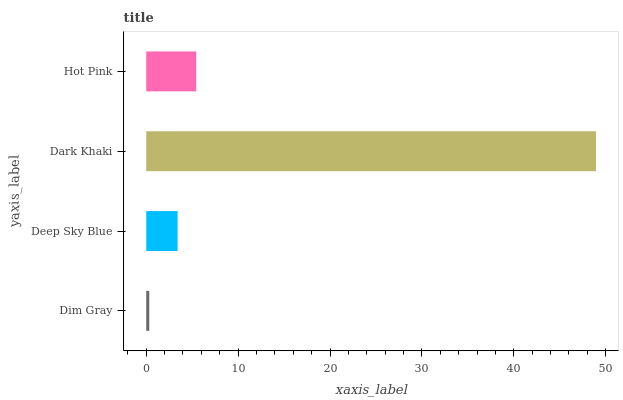Is Dim Gray the minimum?
Answer yes or no. Yes. Is Dark Khaki the maximum?
Answer yes or no. Yes. Is Deep Sky Blue the minimum?
Answer yes or no. No. Is Deep Sky Blue the maximum?
Answer yes or no. No. Is Deep Sky Blue greater than Dim Gray?
Answer yes or no. Yes. Is Dim Gray less than Deep Sky Blue?
Answer yes or no. Yes. Is Dim Gray greater than Deep Sky Blue?
Answer yes or no. No. Is Deep Sky Blue less than Dim Gray?
Answer yes or no. No. Is Hot Pink the high median?
Answer yes or no. Yes. Is Deep Sky Blue the low median?
Answer yes or no. Yes. Is Deep Sky Blue the high median?
Answer yes or no. No. Is Dark Khaki the low median?
Answer yes or no. No. 